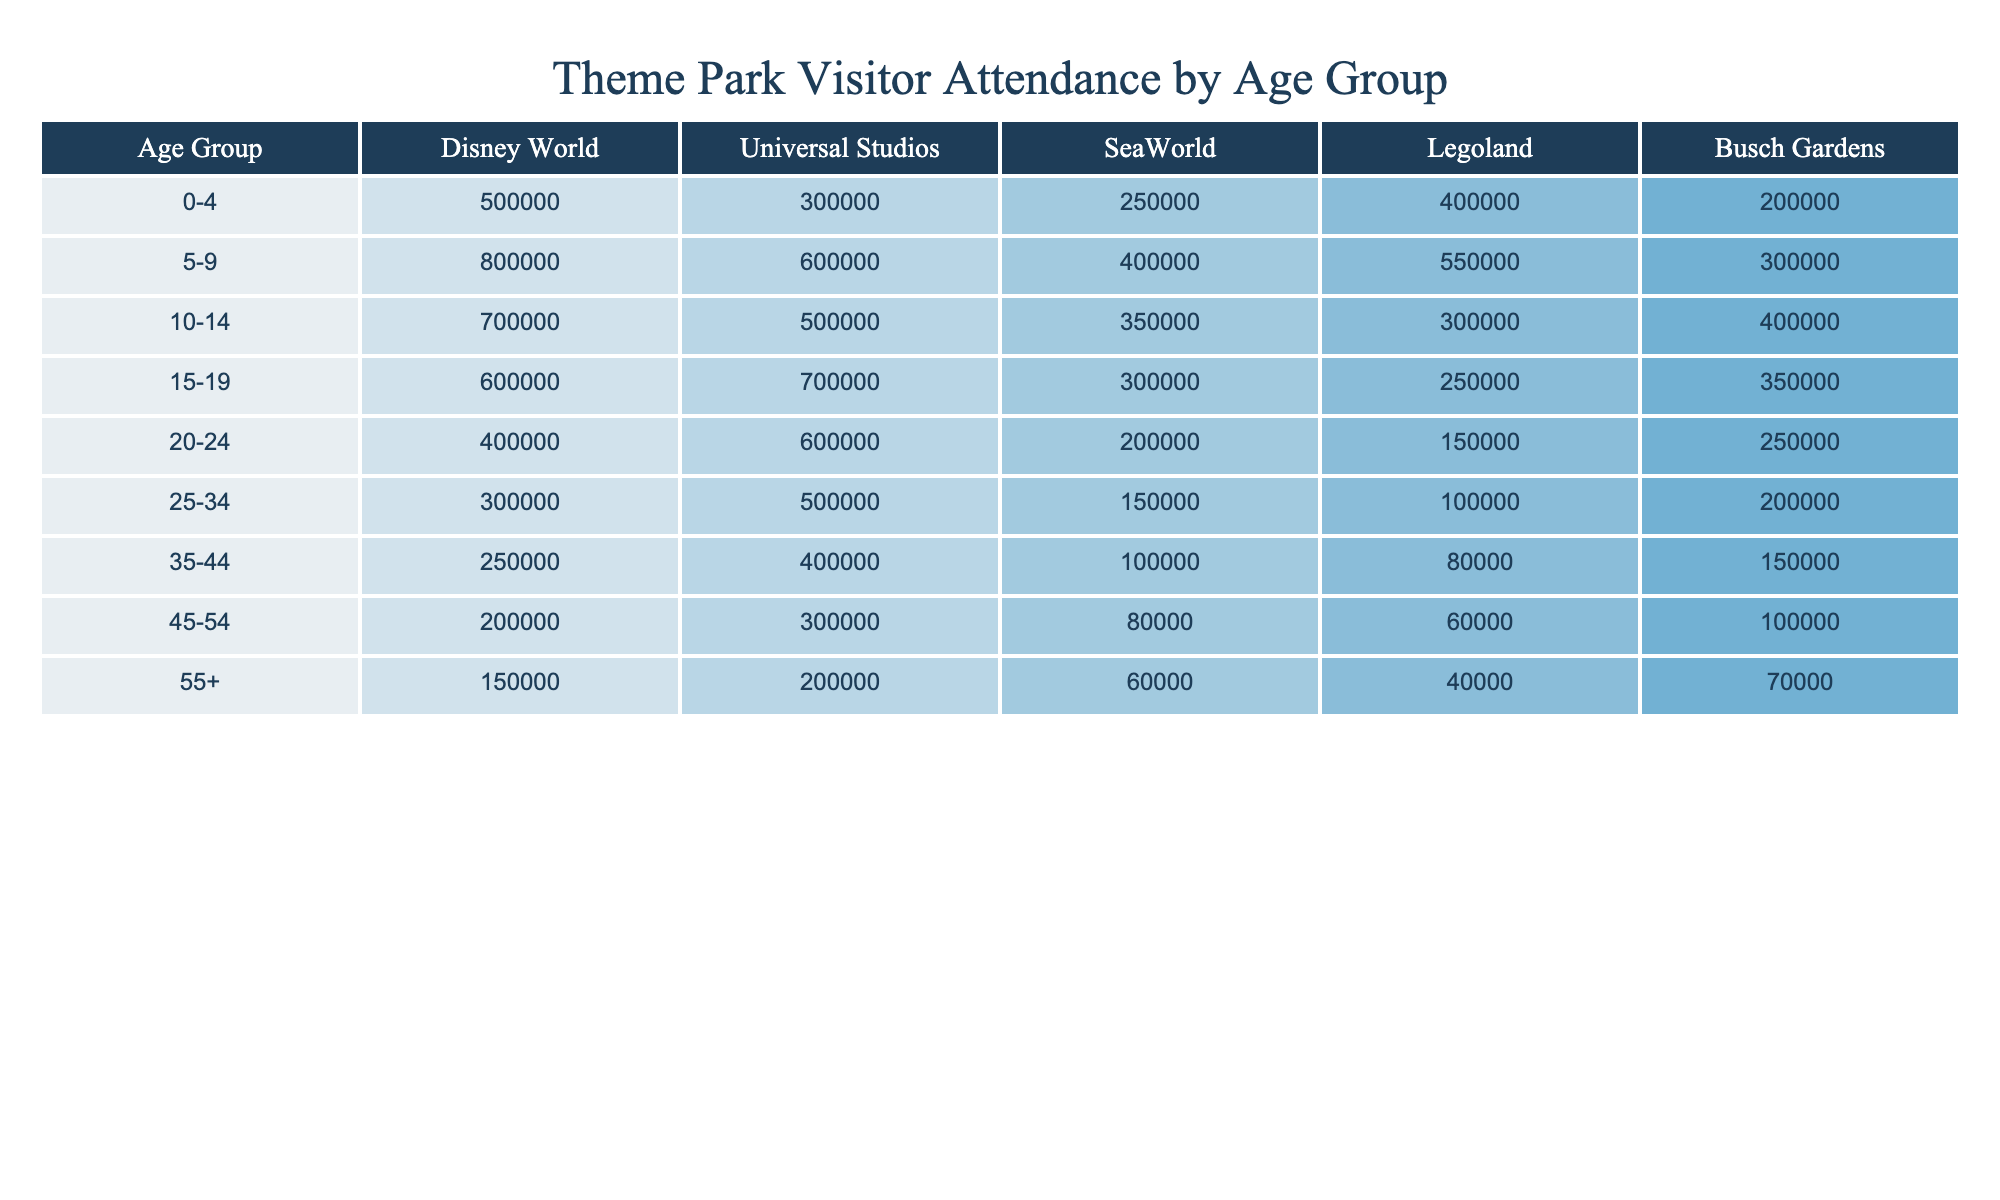What is the total visitor attendance for Disney World across all age groups? To find the total attendance for Disney World, we need to sum the figures from each age group: 500000 + 800000 + 700000 + 600000 + 400000 + 300000 + 250000 + 200000 + 150000 = 4000000.
Answer: 4000000 Which age group has the highest attendance at Universal Studios? Comparing the attendance figures for each age group at Universal Studios, the highest attendance is 700000 from the 15-19 age group.
Answer: 15-19 What is the average attendance at SeaWorld for all age groups? To calculate the average attendance at SeaWorld, we sum the attendance figures: 250000 + 400000 + 350000 + 300000 + 200000 + 150000 + 100000 + 80000 + 60000 = 1980000. There are 9 age groups, so the average is 1980000 / 9 = 220000.
Answer: 220000 Is there an age group with more than 400000 attendees in Busch Gardens? Looking through the attendance figures for Busch Gardens, we see that the age groups 0-4, 5-9, and 10-14 have 400000 or more attendees. Therefore, the statement is true.
Answer: Yes What is the difference in attendance between the 10-14 and 15-19 age groups at Legoland? The attendance figures are 300000 for the 10-14 age group and 250000 for the 15-19 age group at Legoland. The difference is 300000 - 250000 = 50000.
Answer: 50000 Which theme park has the lowest attendance for the 25-34 age group? The attendance figures for the 25-34 age group are: Disney World - 300000, Universal Studios - 500000, SeaWorld - 150000, Legoland - 100000, Busch Gardens - 200000. The lowest attendance is at Legoland with 100000.
Answer: Legoland How many total visitors do the 55+ age group account for across all parks? Summing up the 55+ age group attendance gives us: 150000 + 200000 + 60000 + 40000 + 70000 = 490000.
Answer: 490000 What percentage of the total attendance at SeaWorld comes from the 0-4 age group? The attendance for the 0-4 age group is 250000 and the total attendance at SeaWorld is 1980000. To find the percentage, (250000 / 1980000) * 100 = 12.66%.
Answer: 12.66% Which age group shows the most significant drop in attendance from Disney World to Busch Gardens? The age group 0-4 shows 500000 at Disney World and drops to 200000 at Busch Gardens, which is a drop of 300000. No other age group has a bigger drop.
Answer: 0-4 age group 